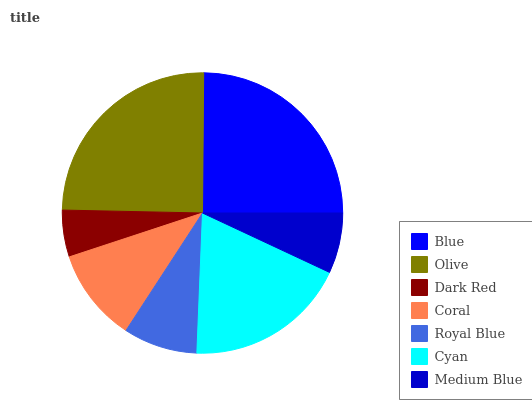Is Dark Red the minimum?
Answer yes or no. Yes. Is Blue the maximum?
Answer yes or no. Yes. Is Olive the minimum?
Answer yes or no. No. Is Olive the maximum?
Answer yes or no. No. Is Blue greater than Olive?
Answer yes or no. Yes. Is Olive less than Blue?
Answer yes or no. Yes. Is Olive greater than Blue?
Answer yes or no. No. Is Blue less than Olive?
Answer yes or no. No. Is Coral the high median?
Answer yes or no. Yes. Is Coral the low median?
Answer yes or no. Yes. Is Royal Blue the high median?
Answer yes or no. No. Is Blue the low median?
Answer yes or no. No. 